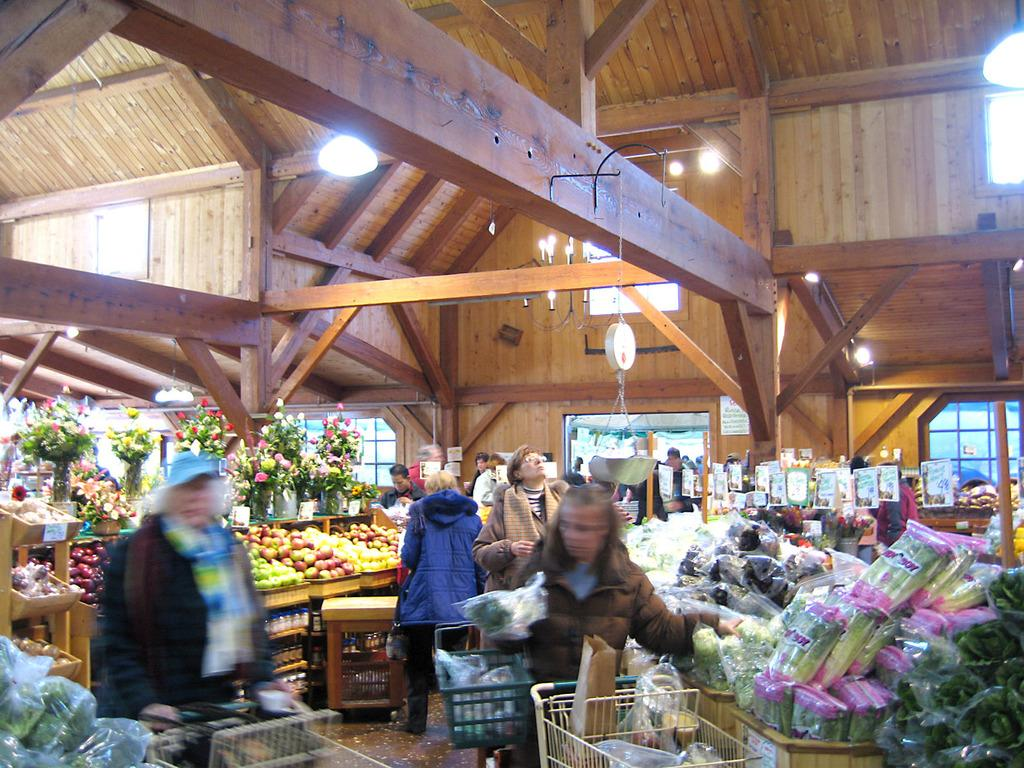Who is present in the image? There are people in the image. What are the people doing in the image? The people are buying vegetables. What other types of food can be seen in the image? There are fruits in the image. Can you describe any other objects in the image? There is an object that looks like a flower in the image. What type of scissors are being used to cut the vegetables in the image? There are no scissors visible in the image, and the people are not cutting any vegetables. Are there any toys present in the image? There are no toys present in the image; it features people buying vegetables and fruits. 